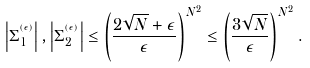<formula> <loc_0><loc_0><loc_500><loc_500>\left | \Sigma _ { 1 } ^ { ^ { ( \epsilon ) } } \right | , \left | \Sigma _ { 2 } ^ { ^ { ( \epsilon ) } } \right | \leq \left ( \frac { 2 \sqrt { N } + \epsilon } { \epsilon } \right ) ^ { N ^ { 2 } } \leq \left ( \frac { 3 \sqrt { N } } { \epsilon } \right ) ^ { N ^ { 2 } } .</formula> 